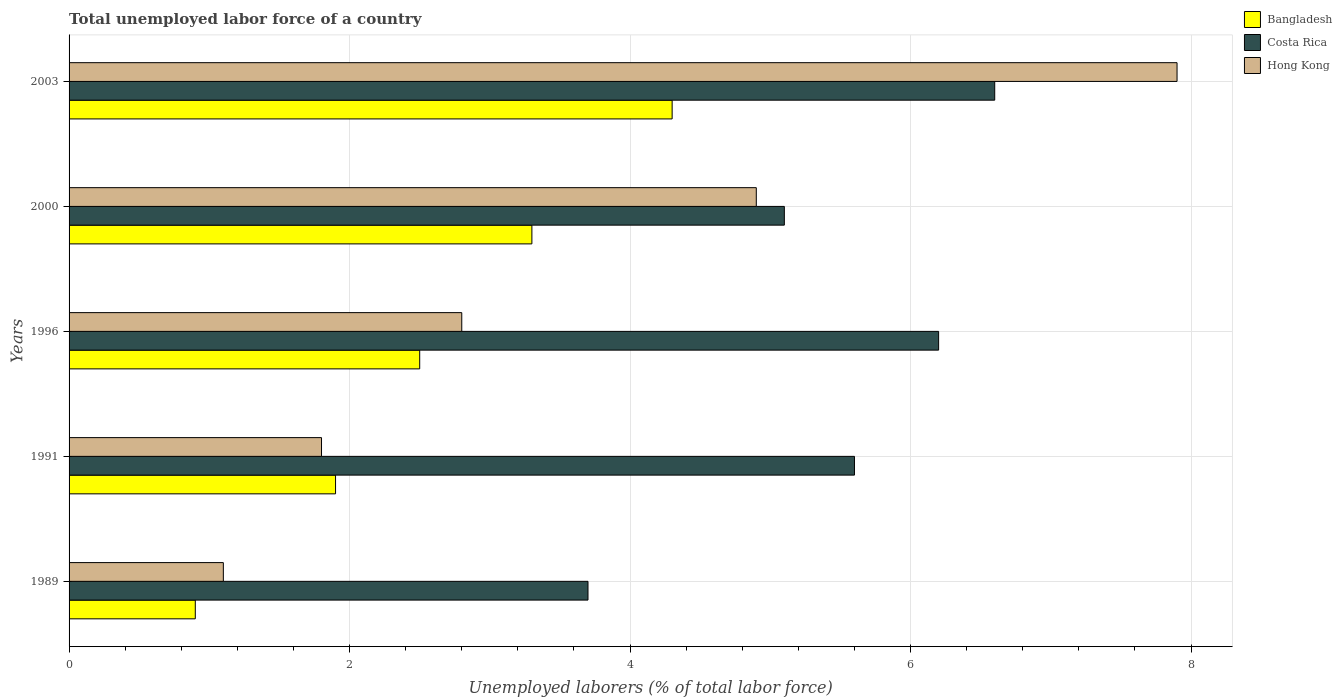How many different coloured bars are there?
Your answer should be very brief. 3. Are the number of bars on each tick of the Y-axis equal?
Offer a terse response. Yes. How many bars are there on the 1st tick from the bottom?
Your response must be concise. 3. What is the total unemployed labor force in Bangladesh in 1989?
Offer a very short reply. 0.9. Across all years, what is the maximum total unemployed labor force in Costa Rica?
Offer a very short reply. 6.6. Across all years, what is the minimum total unemployed labor force in Hong Kong?
Ensure brevity in your answer.  1.1. In which year was the total unemployed labor force in Costa Rica maximum?
Your answer should be compact. 2003. In which year was the total unemployed labor force in Bangladesh minimum?
Your answer should be very brief. 1989. What is the total total unemployed labor force in Bangladesh in the graph?
Keep it short and to the point. 12.9. What is the difference between the total unemployed labor force in Costa Rica in 1991 and that in 1996?
Your response must be concise. -0.6. What is the difference between the total unemployed labor force in Costa Rica in 1991 and the total unemployed labor force in Bangladesh in 1989?
Keep it short and to the point. 4.7. What is the average total unemployed labor force in Bangladesh per year?
Provide a short and direct response. 2.58. In the year 2003, what is the difference between the total unemployed labor force in Hong Kong and total unemployed labor force in Bangladesh?
Your response must be concise. 3.6. What is the ratio of the total unemployed labor force in Bangladesh in 1991 to that in 2003?
Ensure brevity in your answer.  0.44. What is the difference between the highest and the second highest total unemployed labor force in Costa Rica?
Offer a terse response. 0.4. What is the difference between the highest and the lowest total unemployed labor force in Costa Rica?
Provide a succinct answer. 2.9. Is the sum of the total unemployed labor force in Costa Rica in 1989 and 1996 greater than the maximum total unemployed labor force in Hong Kong across all years?
Provide a short and direct response. Yes. What does the 2nd bar from the bottom in 1996 represents?
Your answer should be compact. Costa Rica. Is it the case that in every year, the sum of the total unemployed labor force in Hong Kong and total unemployed labor force in Bangladesh is greater than the total unemployed labor force in Costa Rica?
Your answer should be compact. No. How many bars are there?
Provide a succinct answer. 15. Are all the bars in the graph horizontal?
Offer a terse response. Yes. Does the graph contain any zero values?
Your answer should be compact. No. Does the graph contain grids?
Give a very brief answer. Yes. Where does the legend appear in the graph?
Your answer should be compact. Top right. How are the legend labels stacked?
Provide a short and direct response. Vertical. What is the title of the graph?
Your answer should be very brief. Total unemployed labor force of a country. What is the label or title of the X-axis?
Provide a short and direct response. Unemployed laborers (% of total labor force). What is the label or title of the Y-axis?
Provide a succinct answer. Years. What is the Unemployed laborers (% of total labor force) in Bangladesh in 1989?
Your answer should be compact. 0.9. What is the Unemployed laborers (% of total labor force) of Costa Rica in 1989?
Your response must be concise. 3.7. What is the Unemployed laborers (% of total labor force) in Hong Kong in 1989?
Your response must be concise. 1.1. What is the Unemployed laborers (% of total labor force) of Bangladesh in 1991?
Your answer should be compact. 1.9. What is the Unemployed laborers (% of total labor force) in Costa Rica in 1991?
Provide a short and direct response. 5.6. What is the Unemployed laborers (% of total labor force) of Hong Kong in 1991?
Ensure brevity in your answer.  1.8. What is the Unemployed laborers (% of total labor force) of Costa Rica in 1996?
Your answer should be compact. 6.2. What is the Unemployed laborers (% of total labor force) of Hong Kong in 1996?
Offer a terse response. 2.8. What is the Unemployed laborers (% of total labor force) in Bangladesh in 2000?
Make the answer very short. 3.3. What is the Unemployed laborers (% of total labor force) in Costa Rica in 2000?
Provide a short and direct response. 5.1. What is the Unemployed laborers (% of total labor force) of Hong Kong in 2000?
Ensure brevity in your answer.  4.9. What is the Unemployed laborers (% of total labor force) in Bangladesh in 2003?
Offer a very short reply. 4.3. What is the Unemployed laborers (% of total labor force) in Costa Rica in 2003?
Provide a succinct answer. 6.6. What is the Unemployed laborers (% of total labor force) of Hong Kong in 2003?
Keep it short and to the point. 7.9. Across all years, what is the maximum Unemployed laborers (% of total labor force) in Bangladesh?
Keep it short and to the point. 4.3. Across all years, what is the maximum Unemployed laborers (% of total labor force) of Costa Rica?
Your answer should be compact. 6.6. Across all years, what is the maximum Unemployed laborers (% of total labor force) in Hong Kong?
Your answer should be very brief. 7.9. Across all years, what is the minimum Unemployed laborers (% of total labor force) in Bangladesh?
Your answer should be compact. 0.9. Across all years, what is the minimum Unemployed laborers (% of total labor force) in Costa Rica?
Give a very brief answer. 3.7. Across all years, what is the minimum Unemployed laborers (% of total labor force) in Hong Kong?
Ensure brevity in your answer.  1.1. What is the total Unemployed laborers (% of total labor force) of Costa Rica in the graph?
Your response must be concise. 27.2. What is the difference between the Unemployed laborers (% of total labor force) in Hong Kong in 1989 and that in 1996?
Offer a terse response. -1.7. What is the difference between the Unemployed laborers (% of total labor force) in Bangladesh in 1989 and that in 2000?
Offer a very short reply. -2.4. What is the difference between the Unemployed laborers (% of total labor force) of Costa Rica in 1989 and that in 2000?
Your answer should be very brief. -1.4. What is the difference between the Unemployed laborers (% of total labor force) of Hong Kong in 1989 and that in 2000?
Provide a short and direct response. -3.8. What is the difference between the Unemployed laborers (% of total labor force) in Bangladesh in 1989 and that in 2003?
Keep it short and to the point. -3.4. What is the difference between the Unemployed laborers (% of total labor force) in Costa Rica in 1989 and that in 2003?
Ensure brevity in your answer.  -2.9. What is the difference between the Unemployed laborers (% of total labor force) of Bangladesh in 1991 and that in 1996?
Make the answer very short. -0.6. What is the difference between the Unemployed laborers (% of total labor force) in Costa Rica in 1991 and that in 1996?
Provide a short and direct response. -0.6. What is the difference between the Unemployed laborers (% of total labor force) of Costa Rica in 1991 and that in 2000?
Provide a succinct answer. 0.5. What is the difference between the Unemployed laborers (% of total labor force) in Bangladesh in 1991 and that in 2003?
Keep it short and to the point. -2.4. What is the difference between the Unemployed laborers (% of total labor force) in Hong Kong in 1991 and that in 2003?
Give a very brief answer. -6.1. What is the difference between the Unemployed laborers (% of total labor force) of Hong Kong in 1996 and that in 2000?
Offer a very short reply. -2.1. What is the difference between the Unemployed laborers (% of total labor force) of Bangladesh in 1996 and that in 2003?
Your answer should be very brief. -1.8. What is the difference between the Unemployed laborers (% of total labor force) of Costa Rica in 1996 and that in 2003?
Make the answer very short. -0.4. What is the difference between the Unemployed laborers (% of total labor force) of Hong Kong in 1996 and that in 2003?
Ensure brevity in your answer.  -5.1. What is the difference between the Unemployed laborers (% of total labor force) in Bangladesh in 2000 and that in 2003?
Ensure brevity in your answer.  -1. What is the difference between the Unemployed laborers (% of total labor force) of Costa Rica in 1989 and the Unemployed laborers (% of total labor force) of Hong Kong in 1996?
Your answer should be very brief. 0.9. What is the difference between the Unemployed laborers (% of total labor force) of Bangladesh in 1989 and the Unemployed laborers (% of total labor force) of Costa Rica in 2000?
Offer a terse response. -4.2. What is the difference between the Unemployed laborers (% of total labor force) in Bangladesh in 1989 and the Unemployed laborers (% of total labor force) in Hong Kong in 2000?
Give a very brief answer. -4. What is the difference between the Unemployed laborers (% of total labor force) of Costa Rica in 1991 and the Unemployed laborers (% of total labor force) of Hong Kong in 1996?
Give a very brief answer. 2.8. What is the difference between the Unemployed laborers (% of total labor force) of Bangladesh in 1991 and the Unemployed laborers (% of total labor force) of Hong Kong in 2000?
Offer a very short reply. -3. What is the difference between the Unemployed laborers (% of total labor force) of Costa Rica in 1991 and the Unemployed laborers (% of total labor force) of Hong Kong in 2000?
Ensure brevity in your answer.  0.7. What is the difference between the Unemployed laborers (% of total labor force) of Costa Rica in 1991 and the Unemployed laborers (% of total labor force) of Hong Kong in 2003?
Keep it short and to the point. -2.3. What is the difference between the Unemployed laborers (% of total labor force) in Bangladesh in 1996 and the Unemployed laborers (% of total labor force) in Costa Rica in 2000?
Your response must be concise. -2.6. What is the difference between the Unemployed laborers (% of total labor force) of Bangladesh in 1996 and the Unemployed laborers (% of total labor force) of Hong Kong in 2000?
Provide a succinct answer. -2.4. What is the difference between the Unemployed laborers (% of total labor force) of Costa Rica in 1996 and the Unemployed laborers (% of total labor force) of Hong Kong in 2000?
Offer a very short reply. 1.3. What is the difference between the Unemployed laborers (% of total labor force) of Bangladesh in 1996 and the Unemployed laborers (% of total labor force) of Hong Kong in 2003?
Offer a terse response. -5.4. What is the difference between the Unemployed laborers (% of total labor force) in Bangladesh in 2000 and the Unemployed laborers (% of total labor force) in Hong Kong in 2003?
Offer a terse response. -4.6. What is the difference between the Unemployed laborers (% of total labor force) in Costa Rica in 2000 and the Unemployed laborers (% of total labor force) in Hong Kong in 2003?
Offer a very short reply. -2.8. What is the average Unemployed laborers (% of total labor force) in Bangladesh per year?
Provide a succinct answer. 2.58. What is the average Unemployed laborers (% of total labor force) in Costa Rica per year?
Make the answer very short. 5.44. In the year 1989, what is the difference between the Unemployed laborers (% of total labor force) in Bangladesh and Unemployed laborers (% of total labor force) in Hong Kong?
Give a very brief answer. -0.2. In the year 1989, what is the difference between the Unemployed laborers (% of total labor force) in Costa Rica and Unemployed laborers (% of total labor force) in Hong Kong?
Your response must be concise. 2.6. In the year 1996, what is the difference between the Unemployed laborers (% of total labor force) in Bangladesh and Unemployed laborers (% of total labor force) in Costa Rica?
Provide a short and direct response. -3.7. In the year 1996, what is the difference between the Unemployed laborers (% of total labor force) of Bangladesh and Unemployed laborers (% of total labor force) of Hong Kong?
Make the answer very short. -0.3. In the year 1996, what is the difference between the Unemployed laborers (% of total labor force) of Costa Rica and Unemployed laborers (% of total labor force) of Hong Kong?
Provide a succinct answer. 3.4. In the year 2000, what is the difference between the Unemployed laborers (% of total labor force) in Bangladesh and Unemployed laborers (% of total labor force) in Costa Rica?
Offer a very short reply. -1.8. In the year 2000, what is the difference between the Unemployed laborers (% of total labor force) of Bangladesh and Unemployed laborers (% of total labor force) of Hong Kong?
Ensure brevity in your answer.  -1.6. In the year 2003, what is the difference between the Unemployed laborers (% of total labor force) in Bangladesh and Unemployed laborers (% of total labor force) in Costa Rica?
Offer a terse response. -2.3. In the year 2003, what is the difference between the Unemployed laborers (% of total labor force) in Bangladesh and Unemployed laborers (% of total labor force) in Hong Kong?
Give a very brief answer. -3.6. In the year 2003, what is the difference between the Unemployed laborers (% of total labor force) in Costa Rica and Unemployed laborers (% of total labor force) in Hong Kong?
Your answer should be compact. -1.3. What is the ratio of the Unemployed laborers (% of total labor force) of Bangladesh in 1989 to that in 1991?
Offer a very short reply. 0.47. What is the ratio of the Unemployed laborers (% of total labor force) of Costa Rica in 1989 to that in 1991?
Your answer should be very brief. 0.66. What is the ratio of the Unemployed laborers (% of total labor force) of Hong Kong in 1989 to that in 1991?
Your response must be concise. 0.61. What is the ratio of the Unemployed laborers (% of total labor force) of Bangladesh in 1989 to that in 1996?
Make the answer very short. 0.36. What is the ratio of the Unemployed laborers (% of total labor force) of Costa Rica in 1989 to that in 1996?
Ensure brevity in your answer.  0.6. What is the ratio of the Unemployed laborers (% of total labor force) of Hong Kong in 1989 to that in 1996?
Your answer should be compact. 0.39. What is the ratio of the Unemployed laborers (% of total labor force) in Bangladesh in 1989 to that in 2000?
Offer a terse response. 0.27. What is the ratio of the Unemployed laborers (% of total labor force) in Costa Rica in 1989 to that in 2000?
Keep it short and to the point. 0.73. What is the ratio of the Unemployed laborers (% of total labor force) in Hong Kong in 1989 to that in 2000?
Give a very brief answer. 0.22. What is the ratio of the Unemployed laborers (% of total labor force) of Bangladesh in 1989 to that in 2003?
Offer a very short reply. 0.21. What is the ratio of the Unemployed laborers (% of total labor force) of Costa Rica in 1989 to that in 2003?
Your response must be concise. 0.56. What is the ratio of the Unemployed laborers (% of total labor force) of Hong Kong in 1989 to that in 2003?
Your answer should be compact. 0.14. What is the ratio of the Unemployed laborers (% of total labor force) in Bangladesh in 1991 to that in 1996?
Ensure brevity in your answer.  0.76. What is the ratio of the Unemployed laborers (% of total labor force) of Costa Rica in 1991 to that in 1996?
Your response must be concise. 0.9. What is the ratio of the Unemployed laborers (% of total labor force) of Hong Kong in 1991 to that in 1996?
Your answer should be very brief. 0.64. What is the ratio of the Unemployed laborers (% of total labor force) of Bangladesh in 1991 to that in 2000?
Your response must be concise. 0.58. What is the ratio of the Unemployed laborers (% of total labor force) in Costa Rica in 1991 to that in 2000?
Your answer should be compact. 1.1. What is the ratio of the Unemployed laborers (% of total labor force) in Hong Kong in 1991 to that in 2000?
Your response must be concise. 0.37. What is the ratio of the Unemployed laborers (% of total labor force) of Bangladesh in 1991 to that in 2003?
Provide a short and direct response. 0.44. What is the ratio of the Unemployed laborers (% of total labor force) in Costa Rica in 1991 to that in 2003?
Ensure brevity in your answer.  0.85. What is the ratio of the Unemployed laborers (% of total labor force) in Hong Kong in 1991 to that in 2003?
Offer a very short reply. 0.23. What is the ratio of the Unemployed laborers (% of total labor force) in Bangladesh in 1996 to that in 2000?
Give a very brief answer. 0.76. What is the ratio of the Unemployed laborers (% of total labor force) of Costa Rica in 1996 to that in 2000?
Ensure brevity in your answer.  1.22. What is the ratio of the Unemployed laborers (% of total labor force) of Hong Kong in 1996 to that in 2000?
Provide a succinct answer. 0.57. What is the ratio of the Unemployed laborers (% of total labor force) of Bangladesh in 1996 to that in 2003?
Provide a succinct answer. 0.58. What is the ratio of the Unemployed laborers (% of total labor force) of Costa Rica in 1996 to that in 2003?
Offer a very short reply. 0.94. What is the ratio of the Unemployed laborers (% of total labor force) in Hong Kong in 1996 to that in 2003?
Ensure brevity in your answer.  0.35. What is the ratio of the Unemployed laborers (% of total labor force) of Bangladesh in 2000 to that in 2003?
Keep it short and to the point. 0.77. What is the ratio of the Unemployed laborers (% of total labor force) in Costa Rica in 2000 to that in 2003?
Provide a short and direct response. 0.77. What is the ratio of the Unemployed laborers (% of total labor force) of Hong Kong in 2000 to that in 2003?
Offer a very short reply. 0.62. What is the difference between the highest and the second highest Unemployed laborers (% of total labor force) of Bangladesh?
Offer a terse response. 1. What is the difference between the highest and the second highest Unemployed laborers (% of total labor force) in Costa Rica?
Your answer should be very brief. 0.4. 